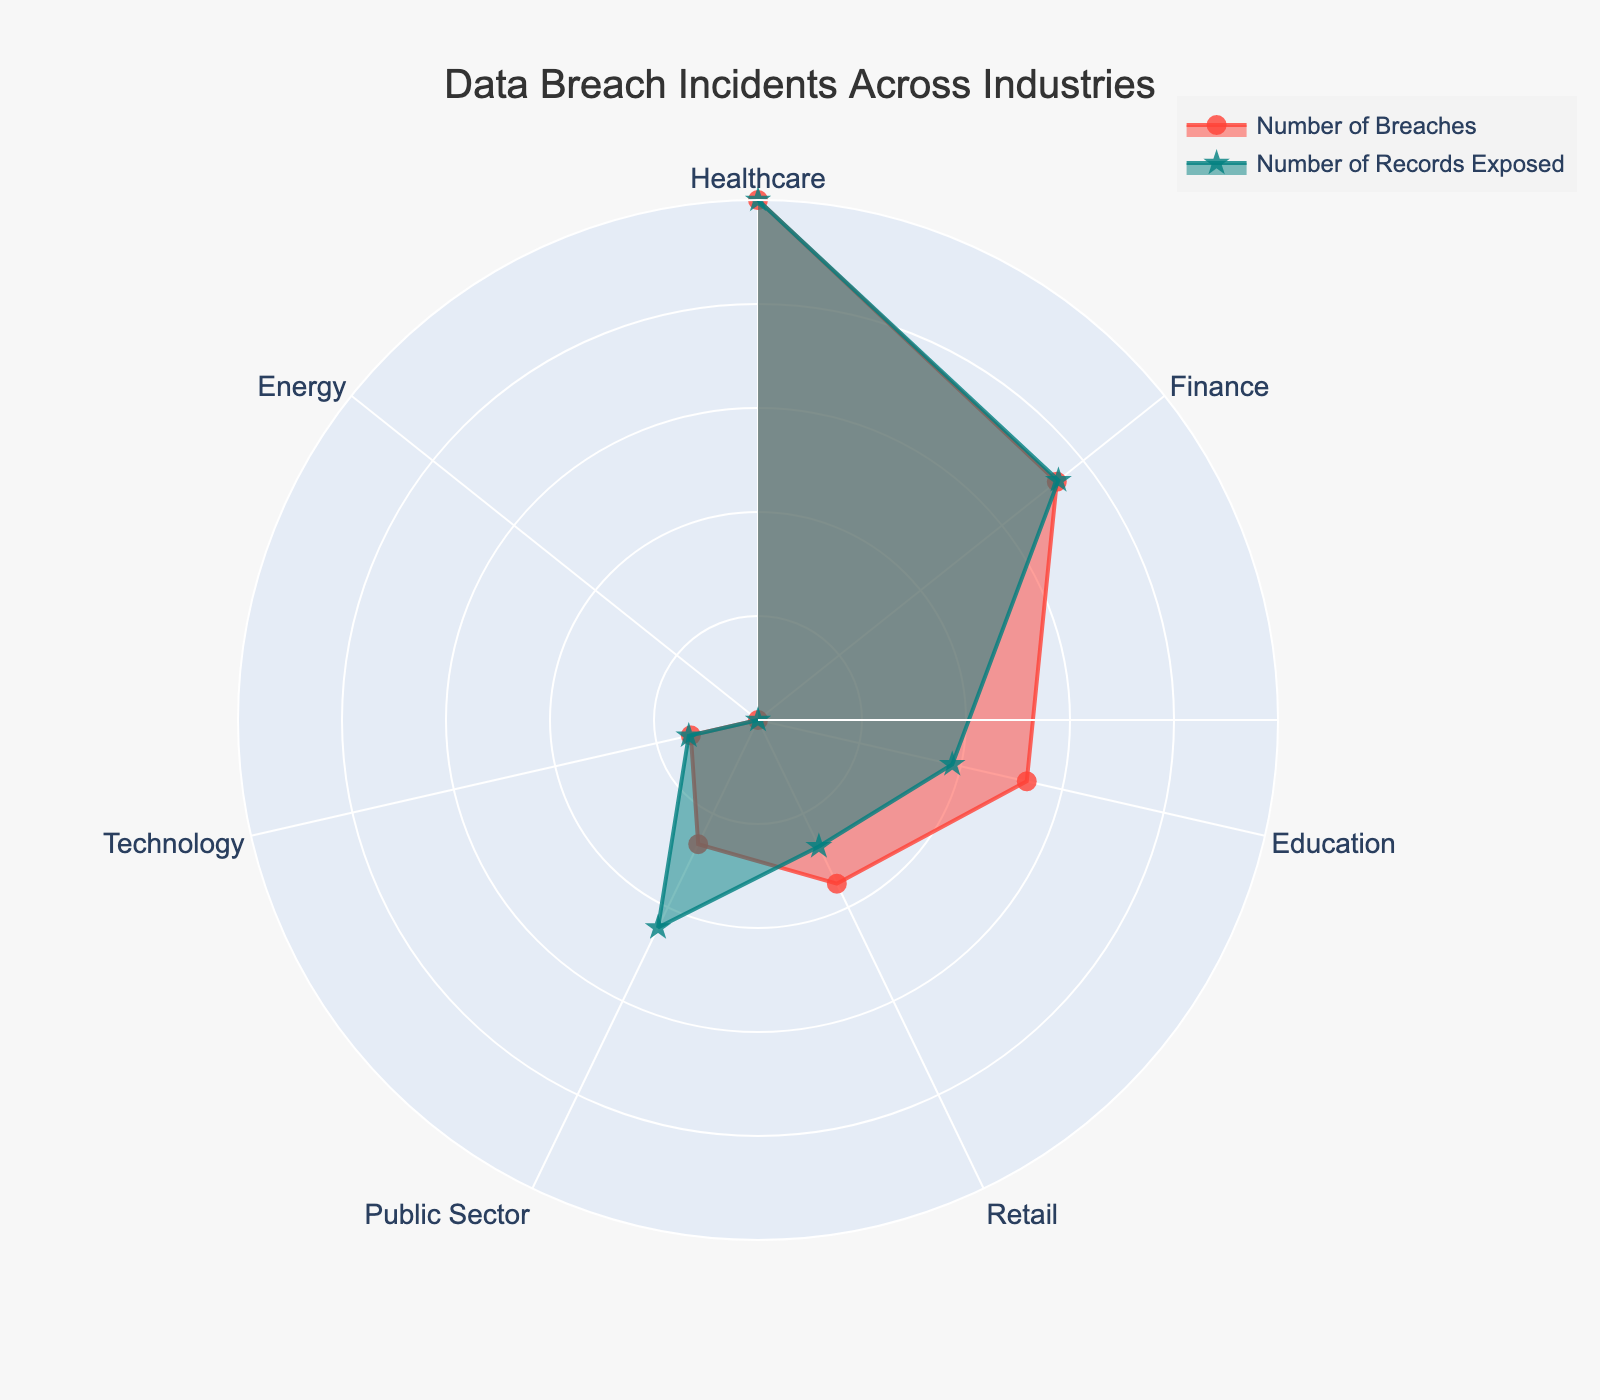What's the title of the figure? The title of the figure is displayed at the top of the chart, usually providing a summary of what the chart is about. In this case, it states "Data Breach Incidents Across Industries".
Answer: Data Breach Incidents Across Industries How are the industries arranged in the chart? The industries are arranged in a circular manner around the polar chart. The names of the industries are placed along the perimeter of the chart in a clockwise direction.
Answer: In a circular manner Which industry has the highest normalized number of breaches? By looking at the plot, we can see the 'Number of Breaches' trace (in red with circle markers) reaches its maximum point at the Healthcare industry.
Answer: Healthcare How does the number of records exposed in the Finance industry compare to that in the Retail industry? We look at the 'Number of Records Exposed' trace (in green with star markers). The Finance industry has a higher normalized value compared to the Retail industry.
Answer: Higher in Finance How many industries are represented in the chart? By counting the number of industries labeled around the polar chart, we can see there are seven different industries.
Answer: Seven Which industry has the lowest normalized number of records exposed? The 'Number of Records Exposed' trace (in green with star markers) shows the lowest point at the Energy industry.
Answer: Energy Are the number of breaches and the number of records exposed normalized in the figure? Yes, both 'Number of Breaches' and 'Number of Records Exposed' are shown in their normalized forms, ranging from 0 to 1 for better visualization.
Answer: Yes Between the Public Sector and Technology industries, which one has more breaches and how does it compare to the records exposed in both industries? The 'Number of Breaches' trace shows a higher normalized value for Public Sector compared to Technology. To compare records exposed, the 'Number of Records Exposed' trace shows Public Sector has a higher normalized value as well. Therefore, Public Sector has more breaches and more records exposed than Technology.
Answer: Public Sector has more breaches and more records exposed In which industry do the normalized values of breaches and records exposed most closely align? We look for the industries where the red and green traces are closest to each other. In the Healthcare industry, the values are quite close to each other.
Answer: Healthcare 